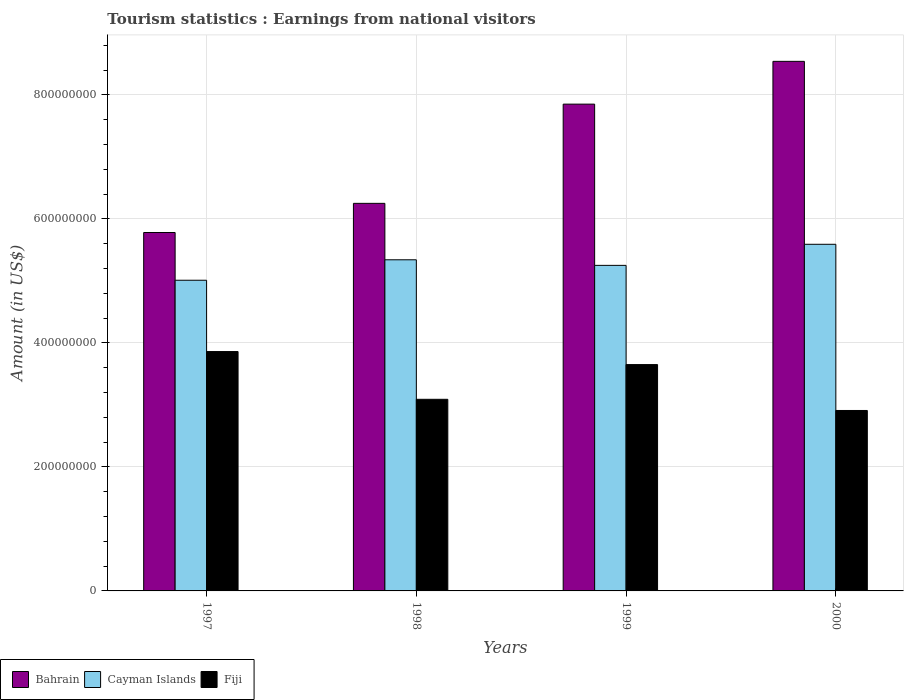Are the number of bars on each tick of the X-axis equal?
Ensure brevity in your answer.  Yes. How many bars are there on the 3rd tick from the right?
Your response must be concise. 3. In how many cases, is the number of bars for a given year not equal to the number of legend labels?
Ensure brevity in your answer.  0. What is the earnings from national visitors in Bahrain in 2000?
Offer a terse response. 8.54e+08. Across all years, what is the maximum earnings from national visitors in Bahrain?
Your answer should be very brief. 8.54e+08. Across all years, what is the minimum earnings from national visitors in Fiji?
Make the answer very short. 2.91e+08. What is the total earnings from national visitors in Cayman Islands in the graph?
Keep it short and to the point. 2.12e+09. What is the difference between the earnings from national visitors in Fiji in 1998 and that in 2000?
Make the answer very short. 1.80e+07. What is the difference between the earnings from national visitors in Bahrain in 1997 and the earnings from national visitors in Fiji in 1999?
Give a very brief answer. 2.13e+08. What is the average earnings from national visitors in Bahrain per year?
Offer a very short reply. 7.10e+08. In the year 2000, what is the difference between the earnings from national visitors in Bahrain and earnings from national visitors in Fiji?
Make the answer very short. 5.63e+08. What is the ratio of the earnings from national visitors in Cayman Islands in 1997 to that in 1998?
Give a very brief answer. 0.94. Is the earnings from national visitors in Bahrain in 1997 less than that in 1998?
Ensure brevity in your answer.  Yes. Is the difference between the earnings from national visitors in Bahrain in 1997 and 1999 greater than the difference between the earnings from national visitors in Fiji in 1997 and 1999?
Provide a short and direct response. No. What is the difference between the highest and the second highest earnings from national visitors in Cayman Islands?
Offer a very short reply. 2.50e+07. What is the difference between the highest and the lowest earnings from national visitors in Cayman Islands?
Your response must be concise. 5.80e+07. Is the sum of the earnings from national visitors in Bahrain in 1997 and 2000 greater than the maximum earnings from national visitors in Fiji across all years?
Provide a succinct answer. Yes. What does the 2nd bar from the left in 1997 represents?
Your response must be concise. Cayman Islands. What does the 2nd bar from the right in 1998 represents?
Offer a terse response. Cayman Islands. Are all the bars in the graph horizontal?
Give a very brief answer. No. Does the graph contain any zero values?
Your response must be concise. No. How many legend labels are there?
Give a very brief answer. 3. What is the title of the graph?
Your answer should be very brief. Tourism statistics : Earnings from national visitors. What is the label or title of the X-axis?
Provide a succinct answer. Years. What is the Amount (in US$) in Bahrain in 1997?
Offer a very short reply. 5.78e+08. What is the Amount (in US$) of Cayman Islands in 1997?
Make the answer very short. 5.01e+08. What is the Amount (in US$) in Fiji in 1997?
Provide a succinct answer. 3.86e+08. What is the Amount (in US$) of Bahrain in 1998?
Offer a very short reply. 6.25e+08. What is the Amount (in US$) of Cayman Islands in 1998?
Your response must be concise. 5.34e+08. What is the Amount (in US$) in Fiji in 1998?
Provide a short and direct response. 3.09e+08. What is the Amount (in US$) in Bahrain in 1999?
Your response must be concise. 7.85e+08. What is the Amount (in US$) of Cayman Islands in 1999?
Your response must be concise. 5.25e+08. What is the Amount (in US$) of Fiji in 1999?
Keep it short and to the point. 3.65e+08. What is the Amount (in US$) in Bahrain in 2000?
Your answer should be very brief. 8.54e+08. What is the Amount (in US$) of Cayman Islands in 2000?
Keep it short and to the point. 5.59e+08. What is the Amount (in US$) in Fiji in 2000?
Your answer should be compact. 2.91e+08. Across all years, what is the maximum Amount (in US$) in Bahrain?
Offer a terse response. 8.54e+08. Across all years, what is the maximum Amount (in US$) in Cayman Islands?
Provide a short and direct response. 5.59e+08. Across all years, what is the maximum Amount (in US$) of Fiji?
Your answer should be very brief. 3.86e+08. Across all years, what is the minimum Amount (in US$) in Bahrain?
Your response must be concise. 5.78e+08. Across all years, what is the minimum Amount (in US$) of Cayman Islands?
Offer a very short reply. 5.01e+08. Across all years, what is the minimum Amount (in US$) of Fiji?
Offer a terse response. 2.91e+08. What is the total Amount (in US$) in Bahrain in the graph?
Offer a very short reply. 2.84e+09. What is the total Amount (in US$) in Cayman Islands in the graph?
Your response must be concise. 2.12e+09. What is the total Amount (in US$) in Fiji in the graph?
Provide a short and direct response. 1.35e+09. What is the difference between the Amount (in US$) in Bahrain in 1997 and that in 1998?
Ensure brevity in your answer.  -4.70e+07. What is the difference between the Amount (in US$) of Cayman Islands in 1997 and that in 1998?
Ensure brevity in your answer.  -3.30e+07. What is the difference between the Amount (in US$) in Fiji in 1997 and that in 1998?
Ensure brevity in your answer.  7.70e+07. What is the difference between the Amount (in US$) in Bahrain in 1997 and that in 1999?
Your answer should be compact. -2.07e+08. What is the difference between the Amount (in US$) in Cayman Islands in 1997 and that in 1999?
Keep it short and to the point. -2.40e+07. What is the difference between the Amount (in US$) in Fiji in 1997 and that in 1999?
Provide a short and direct response. 2.10e+07. What is the difference between the Amount (in US$) of Bahrain in 1997 and that in 2000?
Offer a very short reply. -2.76e+08. What is the difference between the Amount (in US$) in Cayman Islands in 1997 and that in 2000?
Offer a terse response. -5.80e+07. What is the difference between the Amount (in US$) in Fiji in 1997 and that in 2000?
Keep it short and to the point. 9.50e+07. What is the difference between the Amount (in US$) of Bahrain in 1998 and that in 1999?
Your response must be concise. -1.60e+08. What is the difference between the Amount (in US$) in Cayman Islands in 1998 and that in 1999?
Provide a succinct answer. 9.00e+06. What is the difference between the Amount (in US$) in Fiji in 1998 and that in 1999?
Ensure brevity in your answer.  -5.60e+07. What is the difference between the Amount (in US$) in Bahrain in 1998 and that in 2000?
Offer a terse response. -2.29e+08. What is the difference between the Amount (in US$) in Cayman Islands in 1998 and that in 2000?
Offer a terse response. -2.50e+07. What is the difference between the Amount (in US$) of Fiji in 1998 and that in 2000?
Keep it short and to the point. 1.80e+07. What is the difference between the Amount (in US$) of Bahrain in 1999 and that in 2000?
Your answer should be very brief. -6.90e+07. What is the difference between the Amount (in US$) in Cayman Islands in 1999 and that in 2000?
Offer a terse response. -3.40e+07. What is the difference between the Amount (in US$) of Fiji in 1999 and that in 2000?
Provide a succinct answer. 7.40e+07. What is the difference between the Amount (in US$) in Bahrain in 1997 and the Amount (in US$) in Cayman Islands in 1998?
Make the answer very short. 4.40e+07. What is the difference between the Amount (in US$) of Bahrain in 1997 and the Amount (in US$) of Fiji in 1998?
Your response must be concise. 2.69e+08. What is the difference between the Amount (in US$) in Cayman Islands in 1997 and the Amount (in US$) in Fiji in 1998?
Keep it short and to the point. 1.92e+08. What is the difference between the Amount (in US$) of Bahrain in 1997 and the Amount (in US$) of Cayman Islands in 1999?
Offer a very short reply. 5.30e+07. What is the difference between the Amount (in US$) in Bahrain in 1997 and the Amount (in US$) in Fiji in 1999?
Provide a succinct answer. 2.13e+08. What is the difference between the Amount (in US$) of Cayman Islands in 1997 and the Amount (in US$) of Fiji in 1999?
Your answer should be compact. 1.36e+08. What is the difference between the Amount (in US$) of Bahrain in 1997 and the Amount (in US$) of Cayman Islands in 2000?
Your answer should be compact. 1.90e+07. What is the difference between the Amount (in US$) in Bahrain in 1997 and the Amount (in US$) in Fiji in 2000?
Give a very brief answer. 2.87e+08. What is the difference between the Amount (in US$) of Cayman Islands in 1997 and the Amount (in US$) of Fiji in 2000?
Offer a terse response. 2.10e+08. What is the difference between the Amount (in US$) in Bahrain in 1998 and the Amount (in US$) in Cayman Islands in 1999?
Offer a very short reply. 1.00e+08. What is the difference between the Amount (in US$) in Bahrain in 1998 and the Amount (in US$) in Fiji in 1999?
Offer a very short reply. 2.60e+08. What is the difference between the Amount (in US$) of Cayman Islands in 1998 and the Amount (in US$) of Fiji in 1999?
Your response must be concise. 1.69e+08. What is the difference between the Amount (in US$) of Bahrain in 1998 and the Amount (in US$) of Cayman Islands in 2000?
Your answer should be very brief. 6.60e+07. What is the difference between the Amount (in US$) of Bahrain in 1998 and the Amount (in US$) of Fiji in 2000?
Provide a succinct answer. 3.34e+08. What is the difference between the Amount (in US$) of Cayman Islands in 1998 and the Amount (in US$) of Fiji in 2000?
Your answer should be very brief. 2.43e+08. What is the difference between the Amount (in US$) of Bahrain in 1999 and the Amount (in US$) of Cayman Islands in 2000?
Give a very brief answer. 2.26e+08. What is the difference between the Amount (in US$) in Bahrain in 1999 and the Amount (in US$) in Fiji in 2000?
Make the answer very short. 4.94e+08. What is the difference between the Amount (in US$) of Cayman Islands in 1999 and the Amount (in US$) of Fiji in 2000?
Your answer should be very brief. 2.34e+08. What is the average Amount (in US$) in Bahrain per year?
Your response must be concise. 7.10e+08. What is the average Amount (in US$) of Cayman Islands per year?
Provide a short and direct response. 5.30e+08. What is the average Amount (in US$) in Fiji per year?
Offer a terse response. 3.38e+08. In the year 1997, what is the difference between the Amount (in US$) of Bahrain and Amount (in US$) of Cayman Islands?
Your answer should be compact. 7.70e+07. In the year 1997, what is the difference between the Amount (in US$) of Bahrain and Amount (in US$) of Fiji?
Give a very brief answer. 1.92e+08. In the year 1997, what is the difference between the Amount (in US$) of Cayman Islands and Amount (in US$) of Fiji?
Your answer should be compact. 1.15e+08. In the year 1998, what is the difference between the Amount (in US$) of Bahrain and Amount (in US$) of Cayman Islands?
Your response must be concise. 9.10e+07. In the year 1998, what is the difference between the Amount (in US$) of Bahrain and Amount (in US$) of Fiji?
Make the answer very short. 3.16e+08. In the year 1998, what is the difference between the Amount (in US$) of Cayman Islands and Amount (in US$) of Fiji?
Your answer should be very brief. 2.25e+08. In the year 1999, what is the difference between the Amount (in US$) of Bahrain and Amount (in US$) of Cayman Islands?
Provide a succinct answer. 2.60e+08. In the year 1999, what is the difference between the Amount (in US$) in Bahrain and Amount (in US$) in Fiji?
Provide a short and direct response. 4.20e+08. In the year 1999, what is the difference between the Amount (in US$) of Cayman Islands and Amount (in US$) of Fiji?
Offer a very short reply. 1.60e+08. In the year 2000, what is the difference between the Amount (in US$) of Bahrain and Amount (in US$) of Cayman Islands?
Give a very brief answer. 2.95e+08. In the year 2000, what is the difference between the Amount (in US$) of Bahrain and Amount (in US$) of Fiji?
Ensure brevity in your answer.  5.63e+08. In the year 2000, what is the difference between the Amount (in US$) in Cayman Islands and Amount (in US$) in Fiji?
Make the answer very short. 2.68e+08. What is the ratio of the Amount (in US$) in Bahrain in 1997 to that in 1998?
Provide a short and direct response. 0.92. What is the ratio of the Amount (in US$) in Cayman Islands in 1997 to that in 1998?
Make the answer very short. 0.94. What is the ratio of the Amount (in US$) of Fiji in 1997 to that in 1998?
Your response must be concise. 1.25. What is the ratio of the Amount (in US$) of Bahrain in 1997 to that in 1999?
Offer a terse response. 0.74. What is the ratio of the Amount (in US$) in Cayman Islands in 1997 to that in 1999?
Provide a short and direct response. 0.95. What is the ratio of the Amount (in US$) in Fiji in 1997 to that in 1999?
Your answer should be compact. 1.06. What is the ratio of the Amount (in US$) in Bahrain in 1997 to that in 2000?
Keep it short and to the point. 0.68. What is the ratio of the Amount (in US$) in Cayman Islands in 1997 to that in 2000?
Ensure brevity in your answer.  0.9. What is the ratio of the Amount (in US$) in Fiji in 1997 to that in 2000?
Ensure brevity in your answer.  1.33. What is the ratio of the Amount (in US$) of Bahrain in 1998 to that in 1999?
Your response must be concise. 0.8. What is the ratio of the Amount (in US$) of Cayman Islands in 1998 to that in 1999?
Provide a succinct answer. 1.02. What is the ratio of the Amount (in US$) of Fiji in 1998 to that in 1999?
Provide a succinct answer. 0.85. What is the ratio of the Amount (in US$) in Bahrain in 1998 to that in 2000?
Make the answer very short. 0.73. What is the ratio of the Amount (in US$) of Cayman Islands in 1998 to that in 2000?
Give a very brief answer. 0.96. What is the ratio of the Amount (in US$) in Fiji in 1998 to that in 2000?
Keep it short and to the point. 1.06. What is the ratio of the Amount (in US$) of Bahrain in 1999 to that in 2000?
Your answer should be very brief. 0.92. What is the ratio of the Amount (in US$) of Cayman Islands in 1999 to that in 2000?
Your answer should be very brief. 0.94. What is the ratio of the Amount (in US$) of Fiji in 1999 to that in 2000?
Your answer should be very brief. 1.25. What is the difference between the highest and the second highest Amount (in US$) in Bahrain?
Provide a succinct answer. 6.90e+07. What is the difference between the highest and the second highest Amount (in US$) in Cayman Islands?
Give a very brief answer. 2.50e+07. What is the difference between the highest and the second highest Amount (in US$) in Fiji?
Your answer should be compact. 2.10e+07. What is the difference between the highest and the lowest Amount (in US$) of Bahrain?
Provide a short and direct response. 2.76e+08. What is the difference between the highest and the lowest Amount (in US$) of Cayman Islands?
Give a very brief answer. 5.80e+07. What is the difference between the highest and the lowest Amount (in US$) of Fiji?
Make the answer very short. 9.50e+07. 